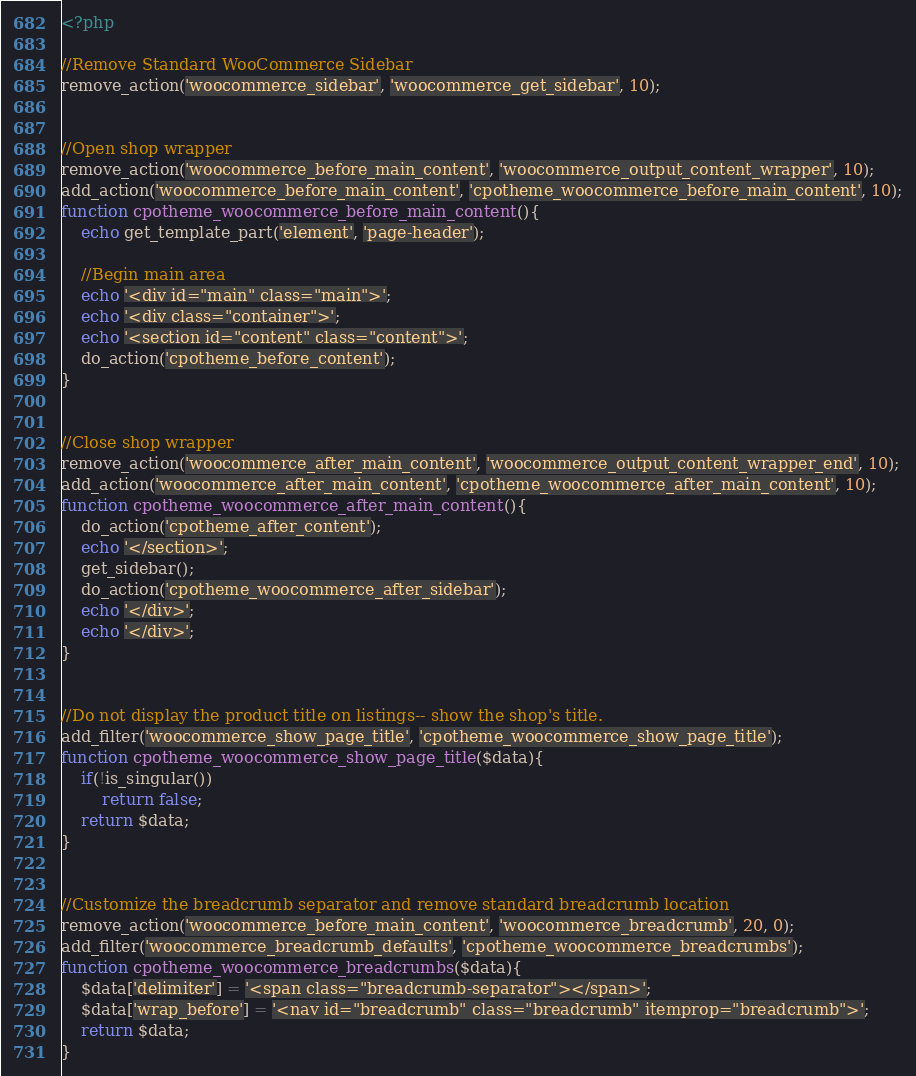Convert code to text. <code><loc_0><loc_0><loc_500><loc_500><_PHP_><?php

//Remove Standard WooCommerce Sidebar
remove_action('woocommerce_sidebar', 'woocommerce_get_sidebar', 10);


//Open shop wrapper
remove_action('woocommerce_before_main_content', 'woocommerce_output_content_wrapper', 10);
add_action('woocommerce_before_main_content', 'cpotheme_woocommerce_before_main_content', 10);
function cpotheme_woocommerce_before_main_content(){
	echo get_template_part('element', 'page-header');
	
	//Begin main area
	echo '<div id="main" class="main">';
	echo '<div class="container">';
	echo '<section id="content" class="content">';
	do_action('cpotheme_before_content');
}


//Close shop wrapper
remove_action('woocommerce_after_main_content', 'woocommerce_output_content_wrapper_end', 10);
add_action('woocommerce_after_main_content', 'cpotheme_woocommerce_after_main_content', 10);
function cpotheme_woocommerce_after_main_content(){
	do_action('cpotheme_after_content');
	echo '</section>';
	get_sidebar();
	do_action('cpotheme_woocommerce_after_sidebar');
	echo '</div>';
	echo '</div>';
}


//Do not display the product title on listings-- show the shop's title.
add_filter('woocommerce_show_page_title', 'cpotheme_woocommerce_show_page_title');
function cpotheme_woocommerce_show_page_title($data){
	if(!is_singular())
		return false;
	return $data;
}


//Customize the breadcrumb separator and remove standard breadcrumb location
remove_action('woocommerce_before_main_content', 'woocommerce_breadcrumb', 20, 0);
add_filter('woocommerce_breadcrumb_defaults', 'cpotheme_woocommerce_breadcrumbs');
function cpotheme_woocommerce_breadcrumbs($data){
	$data['delimiter'] = '<span class="breadcrumb-separator"></span>';
	$data['wrap_before'] = '<nav id="breadcrumb" class="breadcrumb" itemprop="breadcrumb">';
	return $data;
}</code> 